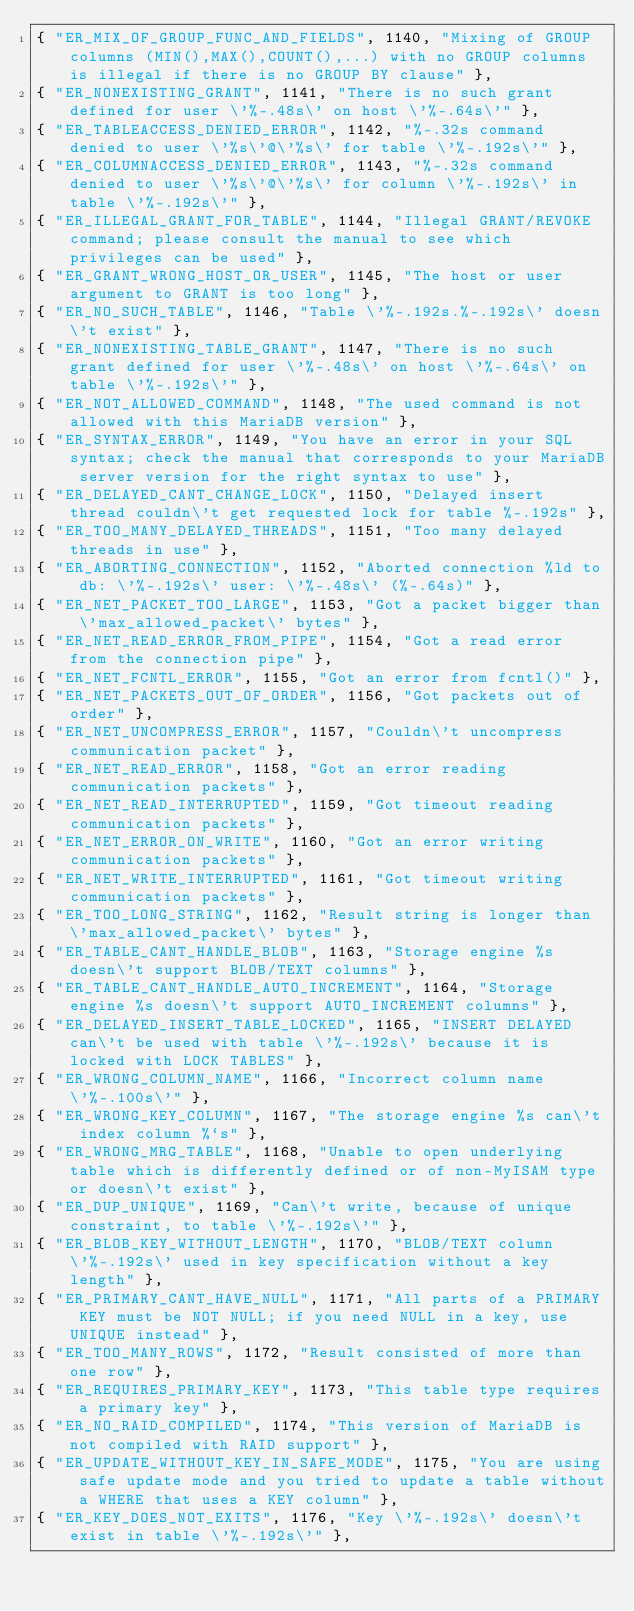<code> <loc_0><loc_0><loc_500><loc_500><_C_>{ "ER_MIX_OF_GROUP_FUNC_AND_FIELDS", 1140, "Mixing of GROUP columns (MIN(),MAX(),COUNT(),...) with no GROUP columns is illegal if there is no GROUP BY clause" },
{ "ER_NONEXISTING_GRANT", 1141, "There is no such grant defined for user \'%-.48s\' on host \'%-.64s\'" },
{ "ER_TABLEACCESS_DENIED_ERROR", 1142, "%-.32s command denied to user \'%s\'@\'%s\' for table \'%-.192s\'" },
{ "ER_COLUMNACCESS_DENIED_ERROR", 1143, "%-.32s command denied to user \'%s\'@\'%s\' for column \'%-.192s\' in table \'%-.192s\'" },
{ "ER_ILLEGAL_GRANT_FOR_TABLE", 1144, "Illegal GRANT/REVOKE command; please consult the manual to see which privileges can be used" },
{ "ER_GRANT_WRONG_HOST_OR_USER", 1145, "The host or user argument to GRANT is too long" },
{ "ER_NO_SUCH_TABLE", 1146, "Table \'%-.192s.%-.192s\' doesn\'t exist" },
{ "ER_NONEXISTING_TABLE_GRANT", 1147, "There is no such grant defined for user \'%-.48s\' on host \'%-.64s\' on table \'%-.192s\'" },
{ "ER_NOT_ALLOWED_COMMAND", 1148, "The used command is not allowed with this MariaDB version" },
{ "ER_SYNTAX_ERROR", 1149, "You have an error in your SQL syntax; check the manual that corresponds to your MariaDB server version for the right syntax to use" },
{ "ER_DELAYED_CANT_CHANGE_LOCK", 1150, "Delayed insert thread couldn\'t get requested lock for table %-.192s" },
{ "ER_TOO_MANY_DELAYED_THREADS", 1151, "Too many delayed threads in use" },
{ "ER_ABORTING_CONNECTION", 1152, "Aborted connection %ld to db: \'%-.192s\' user: \'%-.48s\' (%-.64s)" },
{ "ER_NET_PACKET_TOO_LARGE", 1153, "Got a packet bigger than \'max_allowed_packet\' bytes" },
{ "ER_NET_READ_ERROR_FROM_PIPE", 1154, "Got a read error from the connection pipe" },
{ "ER_NET_FCNTL_ERROR", 1155, "Got an error from fcntl()" },
{ "ER_NET_PACKETS_OUT_OF_ORDER", 1156, "Got packets out of order" },
{ "ER_NET_UNCOMPRESS_ERROR", 1157, "Couldn\'t uncompress communication packet" },
{ "ER_NET_READ_ERROR", 1158, "Got an error reading communication packets" },
{ "ER_NET_READ_INTERRUPTED", 1159, "Got timeout reading communication packets" },
{ "ER_NET_ERROR_ON_WRITE", 1160, "Got an error writing communication packets" },
{ "ER_NET_WRITE_INTERRUPTED", 1161, "Got timeout writing communication packets" },
{ "ER_TOO_LONG_STRING", 1162, "Result string is longer than \'max_allowed_packet\' bytes" },
{ "ER_TABLE_CANT_HANDLE_BLOB", 1163, "Storage engine %s doesn\'t support BLOB/TEXT columns" },
{ "ER_TABLE_CANT_HANDLE_AUTO_INCREMENT", 1164, "Storage engine %s doesn\'t support AUTO_INCREMENT columns" },
{ "ER_DELAYED_INSERT_TABLE_LOCKED", 1165, "INSERT DELAYED can\'t be used with table \'%-.192s\' because it is locked with LOCK TABLES" },
{ "ER_WRONG_COLUMN_NAME", 1166, "Incorrect column name \'%-.100s\'" },
{ "ER_WRONG_KEY_COLUMN", 1167, "The storage engine %s can\'t index column %`s" },
{ "ER_WRONG_MRG_TABLE", 1168, "Unable to open underlying table which is differently defined or of non-MyISAM type or doesn\'t exist" },
{ "ER_DUP_UNIQUE", 1169, "Can\'t write, because of unique constraint, to table \'%-.192s\'" },
{ "ER_BLOB_KEY_WITHOUT_LENGTH", 1170, "BLOB/TEXT column \'%-.192s\' used in key specification without a key length" },
{ "ER_PRIMARY_CANT_HAVE_NULL", 1171, "All parts of a PRIMARY KEY must be NOT NULL; if you need NULL in a key, use UNIQUE instead" },
{ "ER_TOO_MANY_ROWS", 1172, "Result consisted of more than one row" },
{ "ER_REQUIRES_PRIMARY_KEY", 1173, "This table type requires a primary key" },
{ "ER_NO_RAID_COMPILED", 1174, "This version of MariaDB is not compiled with RAID support" },
{ "ER_UPDATE_WITHOUT_KEY_IN_SAFE_MODE", 1175, "You are using safe update mode and you tried to update a table without a WHERE that uses a KEY column" },
{ "ER_KEY_DOES_NOT_EXITS", 1176, "Key \'%-.192s\' doesn\'t exist in table \'%-.192s\'" },</code> 